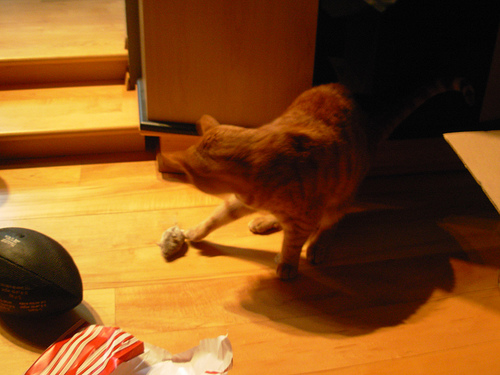<image>
Can you confirm if the cat is above the mouse? Yes. The cat is positioned above the mouse in the vertical space, higher up in the scene. 